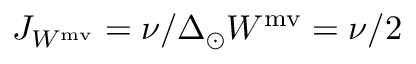Convert formula to latex. <formula><loc_0><loc_0><loc_500><loc_500>J _ { W ^ { m v } } = \nu / \Delta _ { \odot } W ^ { m v } = \nu / 2</formula> 